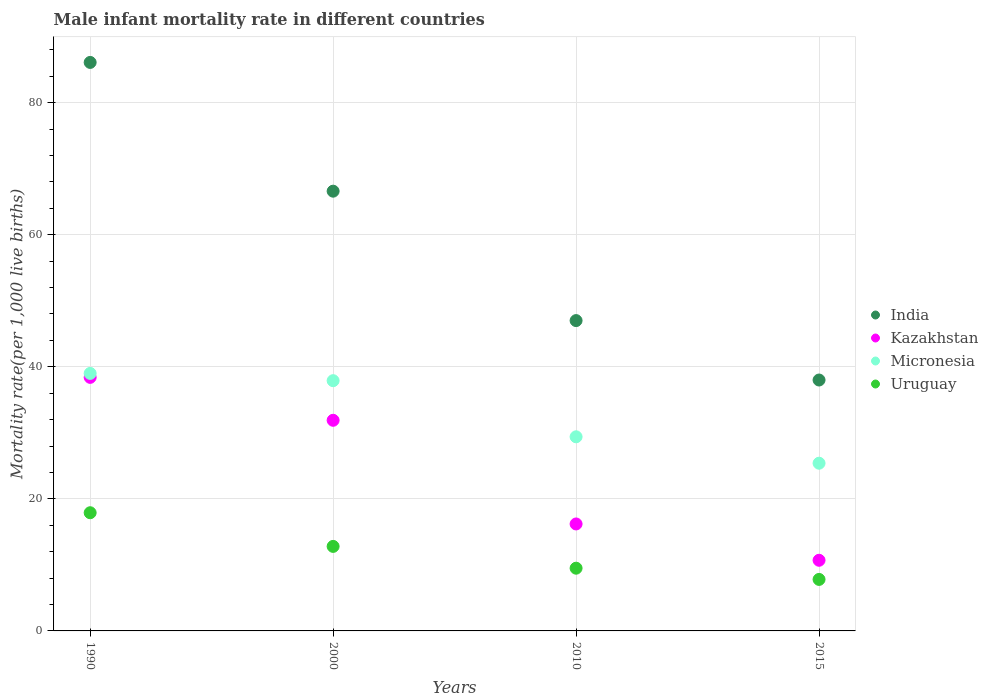Is the number of dotlines equal to the number of legend labels?
Your response must be concise. Yes. What is the male infant mortality rate in Micronesia in 2015?
Give a very brief answer. 25.4. Across all years, what is the maximum male infant mortality rate in Kazakhstan?
Give a very brief answer. 38.4. Across all years, what is the minimum male infant mortality rate in Kazakhstan?
Give a very brief answer. 10.7. In which year was the male infant mortality rate in Kazakhstan maximum?
Offer a very short reply. 1990. In which year was the male infant mortality rate in Micronesia minimum?
Provide a short and direct response. 2015. What is the total male infant mortality rate in Kazakhstan in the graph?
Ensure brevity in your answer.  97.2. What is the difference between the male infant mortality rate in Kazakhstan in 1990 and that in 2015?
Make the answer very short. 27.7. What is the difference between the male infant mortality rate in India in 2015 and the male infant mortality rate in Micronesia in 2000?
Make the answer very short. 0.1. What is the average male infant mortality rate in Kazakhstan per year?
Give a very brief answer. 24.3. In the year 2010, what is the difference between the male infant mortality rate in Micronesia and male infant mortality rate in India?
Give a very brief answer. -17.6. In how many years, is the male infant mortality rate in India greater than 72?
Offer a very short reply. 1. What is the ratio of the male infant mortality rate in India in 1990 to that in 2010?
Your answer should be compact. 1.83. Is the male infant mortality rate in Uruguay in 1990 less than that in 2015?
Your response must be concise. No. Is the difference between the male infant mortality rate in Micronesia in 2000 and 2010 greater than the difference between the male infant mortality rate in India in 2000 and 2010?
Give a very brief answer. No. What is the difference between the highest and the second highest male infant mortality rate in Uruguay?
Ensure brevity in your answer.  5.1. What is the difference between the highest and the lowest male infant mortality rate in India?
Offer a very short reply. 48.1. In how many years, is the male infant mortality rate in Kazakhstan greater than the average male infant mortality rate in Kazakhstan taken over all years?
Make the answer very short. 2. Does the male infant mortality rate in Uruguay monotonically increase over the years?
Provide a succinct answer. No. How many dotlines are there?
Your answer should be compact. 4. Does the graph contain grids?
Offer a terse response. Yes. Where does the legend appear in the graph?
Your answer should be very brief. Center right. What is the title of the graph?
Ensure brevity in your answer.  Male infant mortality rate in different countries. What is the label or title of the X-axis?
Your answer should be very brief. Years. What is the label or title of the Y-axis?
Give a very brief answer. Mortality rate(per 1,0 live births). What is the Mortality rate(per 1,000 live births) in India in 1990?
Give a very brief answer. 86.1. What is the Mortality rate(per 1,000 live births) in Kazakhstan in 1990?
Ensure brevity in your answer.  38.4. What is the Mortality rate(per 1,000 live births) in India in 2000?
Your response must be concise. 66.6. What is the Mortality rate(per 1,000 live births) of Kazakhstan in 2000?
Provide a succinct answer. 31.9. What is the Mortality rate(per 1,000 live births) in Micronesia in 2000?
Provide a succinct answer. 37.9. What is the Mortality rate(per 1,000 live births) of Kazakhstan in 2010?
Your response must be concise. 16.2. What is the Mortality rate(per 1,000 live births) in Micronesia in 2010?
Your response must be concise. 29.4. What is the Mortality rate(per 1,000 live births) of Kazakhstan in 2015?
Your answer should be very brief. 10.7. What is the Mortality rate(per 1,000 live births) of Micronesia in 2015?
Offer a terse response. 25.4. Across all years, what is the maximum Mortality rate(per 1,000 live births) of India?
Provide a succinct answer. 86.1. Across all years, what is the maximum Mortality rate(per 1,000 live births) in Kazakhstan?
Offer a terse response. 38.4. Across all years, what is the maximum Mortality rate(per 1,000 live births) in Micronesia?
Provide a succinct answer. 39. Across all years, what is the maximum Mortality rate(per 1,000 live births) of Uruguay?
Provide a succinct answer. 17.9. Across all years, what is the minimum Mortality rate(per 1,000 live births) of India?
Keep it short and to the point. 38. Across all years, what is the minimum Mortality rate(per 1,000 live births) in Micronesia?
Provide a succinct answer. 25.4. What is the total Mortality rate(per 1,000 live births) in India in the graph?
Keep it short and to the point. 237.7. What is the total Mortality rate(per 1,000 live births) of Kazakhstan in the graph?
Your answer should be compact. 97.2. What is the total Mortality rate(per 1,000 live births) of Micronesia in the graph?
Offer a very short reply. 131.7. What is the difference between the Mortality rate(per 1,000 live births) in India in 1990 and that in 2000?
Your answer should be very brief. 19.5. What is the difference between the Mortality rate(per 1,000 live births) of Kazakhstan in 1990 and that in 2000?
Keep it short and to the point. 6.5. What is the difference between the Mortality rate(per 1,000 live births) in Micronesia in 1990 and that in 2000?
Your answer should be very brief. 1.1. What is the difference between the Mortality rate(per 1,000 live births) of Uruguay in 1990 and that in 2000?
Your response must be concise. 5.1. What is the difference between the Mortality rate(per 1,000 live births) of India in 1990 and that in 2010?
Your answer should be compact. 39.1. What is the difference between the Mortality rate(per 1,000 live births) in Micronesia in 1990 and that in 2010?
Keep it short and to the point. 9.6. What is the difference between the Mortality rate(per 1,000 live births) in Uruguay in 1990 and that in 2010?
Provide a short and direct response. 8.4. What is the difference between the Mortality rate(per 1,000 live births) in India in 1990 and that in 2015?
Ensure brevity in your answer.  48.1. What is the difference between the Mortality rate(per 1,000 live births) of Kazakhstan in 1990 and that in 2015?
Your response must be concise. 27.7. What is the difference between the Mortality rate(per 1,000 live births) in Micronesia in 1990 and that in 2015?
Offer a very short reply. 13.6. What is the difference between the Mortality rate(per 1,000 live births) of India in 2000 and that in 2010?
Provide a short and direct response. 19.6. What is the difference between the Mortality rate(per 1,000 live births) of Micronesia in 2000 and that in 2010?
Ensure brevity in your answer.  8.5. What is the difference between the Mortality rate(per 1,000 live births) in Uruguay in 2000 and that in 2010?
Give a very brief answer. 3.3. What is the difference between the Mortality rate(per 1,000 live births) in India in 2000 and that in 2015?
Offer a terse response. 28.6. What is the difference between the Mortality rate(per 1,000 live births) in Kazakhstan in 2000 and that in 2015?
Offer a terse response. 21.2. What is the difference between the Mortality rate(per 1,000 live births) in India in 2010 and that in 2015?
Offer a terse response. 9. What is the difference between the Mortality rate(per 1,000 live births) of Kazakhstan in 2010 and that in 2015?
Keep it short and to the point. 5.5. What is the difference between the Mortality rate(per 1,000 live births) in Micronesia in 2010 and that in 2015?
Offer a very short reply. 4. What is the difference between the Mortality rate(per 1,000 live births) of India in 1990 and the Mortality rate(per 1,000 live births) of Kazakhstan in 2000?
Provide a succinct answer. 54.2. What is the difference between the Mortality rate(per 1,000 live births) of India in 1990 and the Mortality rate(per 1,000 live births) of Micronesia in 2000?
Provide a short and direct response. 48.2. What is the difference between the Mortality rate(per 1,000 live births) in India in 1990 and the Mortality rate(per 1,000 live births) in Uruguay in 2000?
Provide a short and direct response. 73.3. What is the difference between the Mortality rate(per 1,000 live births) of Kazakhstan in 1990 and the Mortality rate(per 1,000 live births) of Uruguay in 2000?
Ensure brevity in your answer.  25.6. What is the difference between the Mortality rate(per 1,000 live births) of Micronesia in 1990 and the Mortality rate(per 1,000 live births) of Uruguay in 2000?
Your answer should be compact. 26.2. What is the difference between the Mortality rate(per 1,000 live births) of India in 1990 and the Mortality rate(per 1,000 live births) of Kazakhstan in 2010?
Make the answer very short. 69.9. What is the difference between the Mortality rate(per 1,000 live births) in India in 1990 and the Mortality rate(per 1,000 live births) in Micronesia in 2010?
Provide a short and direct response. 56.7. What is the difference between the Mortality rate(per 1,000 live births) of India in 1990 and the Mortality rate(per 1,000 live births) of Uruguay in 2010?
Offer a very short reply. 76.6. What is the difference between the Mortality rate(per 1,000 live births) in Kazakhstan in 1990 and the Mortality rate(per 1,000 live births) in Uruguay in 2010?
Provide a short and direct response. 28.9. What is the difference between the Mortality rate(per 1,000 live births) of Micronesia in 1990 and the Mortality rate(per 1,000 live births) of Uruguay in 2010?
Ensure brevity in your answer.  29.5. What is the difference between the Mortality rate(per 1,000 live births) in India in 1990 and the Mortality rate(per 1,000 live births) in Kazakhstan in 2015?
Ensure brevity in your answer.  75.4. What is the difference between the Mortality rate(per 1,000 live births) in India in 1990 and the Mortality rate(per 1,000 live births) in Micronesia in 2015?
Your answer should be compact. 60.7. What is the difference between the Mortality rate(per 1,000 live births) in India in 1990 and the Mortality rate(per 1,000 live births) in Uruguay in 2015?
Offer a very short reply. 78.3. What is the difference between the Mortality rate(per 1,000 live births) in Kazakhstan in 1990 and the Mortality rate(per 1,000 live births) in Micronesia in 2015?
Provide a succinct answer. 13. What is the difference between the Mortality rate(per 1,000 live births) in Kazakhstan in 1990 and the Mortality rate(per 1,000 live births) in Uruguay in 2015?
Your response must be concise. 30.6. What is the difference between the Mortality rate(per 1,000 live births) in Micronesia in 1990 and the Mortality rate(per 1,000 live births) in Uruguay in 2015?
Ensure brevity in your answer.  31.2. What is the difference between the Mortality rate(per 1,000 live births) in India in 2000 and the Mortality rate(per 1,000 live births) in Kazakhstan in 2010?
Provide a short and direct response. 50.4. What is the difference between the Mortality rate(per 1,000 live births) of India in 2000 and the Mortality rate(per 1,000 live births) of Micronesia in 2010?
Your answer should be compact. 37.2. What is the difference between the Mortality rate(per 1,000 live births) in India in 2000 and the Mortality rate(per 1,000 live births) in Uruguay in 2010?
Your answer should be compact. 57.1. What is the difference between the Mortality rate(per 1,000 live births) in Kazakhstan in 2000 and the Mortality rate(per 1,000 live births) in Uruguay in 2010?
Offer a terse response. 22.4. What is the difference between the Mortality rate(per 1,000 live births) of Micronesia in 2000 and the Mortality rate(per 1,000 live births) of Uruguay in 2010?
Ensure brevity in your answer.  28.4. What is the difference between the Mortality rate(per 1,000 live births) in India in 2000 and the Mortality rate(per 1,000 live births) in Kazakhstan in 2015?
Make the answer very short. 55.9. What is the difference between the Mortality rate(per 1,000 live births) in India in 2000 and the Mortality rate(per 1,000 live births) in Micronesia in 2015?
Your answer should be very brief. 41.2. What is the difference between the Mortality rate(per 1,000 live births) of India in 2000 and the Mortality rate(per 1,000 live births) of Uruguay in 2015?
Your answer should be compact. 58.8. What is the difference between the Mortality rate(per 1,000 live births) in Kazakhstan in 2000 and the Mortality rate(per 1,000 live births) in Uruguay in 2015?
Your response must be concise. 24.1. What is the difference between the Mortality rate(per 1,000 live births) of Micronesia in 2000 and the Mortality rate(per 1,000 live births) of Uruguay in 2015?
Offer a very short reply. 30.1. What is the difference between the Mortality rate(per 1,000 live births) in India in 2010 and the Mortality rate(per 1,000 live births) in Kazakhstan in 2015?
Provide a succinct answer. 36.3. What is the difference between the Mortality rate(per 1,000 live births) in India in 2010 and the Mortality rate(per 1,000 live births) in Micronesia in 2015?
Provide a succinct answer. 21.6. What is the difference between the Mortality rate(per 1,000 live births) of India in 2010 and the Mortality rate(per 1,000 live births) of Uruguay in 2015?
Make the answer very short. 39.2. What is the difference between the Mortality rate(per 1,000 live births) of Kazakhstan in 2010 and the Mortality rate(per 1,000 live births) of Micronesia in 2015?
Your answer should be very brief. -9.2. What is the difference between the Mortality rate(per 1,000 live births) in Kazakhstan in 2010 and the Mortality rate(per 1,000 live births) in Uruguay in 2015?
Provide a short and direct response. 8.4. What is the difference between the Mortality rate(per 1,000 live births) in Micronesia in 2010 and the Mortality rate(per 1,000 live births) in Uruguay in 2015?
Your answer should be very brief. 21.6. What is the average Mortality rate(per 1,000 live births) in India per year?
Your answer should be very brief. 59.42. What is the average Mortality rate(per 1,000 live births) in Kazakhstan per year?
Offer a very short reply. 24.3. What is the average Mortality rate(per 1,000 live births) of Micronesia per year?
Your answer should be very brief. 32.92. In the year 1990, what is the difference between the Mortality rate(per 1,000 live births) in India and Mortality rate(per 1,000 live births) in Kazakhstan?
Provide a succinct answer. 47.7. In the year 1990, what is the difference between the Mortality rate(per 1,000 live births) of India and Mortality rate(per 1,000 live births) of Micronesia?
Make the answer very short. 47.1. In the year 1990, what is the difference between the Mortality rate(per 1,000 live births) in India and Mortality rate(per 1,000 live births) in Uruguay?
Your answer should be very brief. 68.2. In the year 1990, what is the difference between the Mortality rate(per 1,000 live births) of Kazakhstan and Mortality rate(per 1,000 live births) of Micronesia?
Your answer should be compact. -0.6. In the year 1990, what is the difference between the Mortality rate(per 1,000 live births) of Kazakhstan and Mortality rate(per 1,000 live births) of Uruguay?
Make the answer very short. 20.5. In the year 1990, what is the difference between the Mortality rate(per 1,000 live births) in Micronesia and Mortality rate(per 1,000 live births) in Uruguay?
Your answer should be compact. 21.1. In the year 2000, what is the difference between the Mortality rate(per 1,000 live births) of India and Mortality rate(per 1,000 live births) of Kazakhstan?
Offer a very short reply. 34.7. In the year 2000, what is the difference between the Mortality rate(per 1,000 live births) in India and Mortality rate(per 1,000 live births) in Micronesia?
Your answer should be very brief. 28.7. In the year 2000, what is the difference between the Mortality rate(per 1,000 live births) in India and Mortality rate(per 1,000 live births) in Uruguay?
Offer a very short reply. 53.8. In the year 2000, what is the difference between the Mortality rate(per 1,000 live births) of Kazakhstan and Mortality rate(per 1,000 live births) of Micronesia?
Your answer should be very brief. -6. In the year 2000, what is the difference between the Mortality rate(per 1,000 live births) of Kazakhstan and Mortality rate(per 1,000 live births) of Uruguay?
Your response must be concise. 19.1. In the year 2000, what is the difference between the Mortality rate(per 1,000 live births) in Micronesia and Mortality rate(per 1,000 live births) in Uruguay?
Offer a terse response. 25.1. In the year 2010, what is the difference between the Mortality rate(per 1,000 live births) of India and Mortality rate(per 1,000 live births) of Kazakhstan?
Give a very brief answer. 30.8. In the year 2010, what is the difference between the Mortality rate(per 1,000 live births) in India and Mortality rate(per 1,000 live births) in Micronesia?
Your response must be concise. 17.6. In the year 2010, what is the difference between the Mortality rate(per 1,000 live births) of India and Mortality rate(per 1,000 live births) of Uruguay?
Make the answer very short. 37.5. In the year 2010, what is the difference between the Mortality rate(per 1,000 live births) of Kazakhstan and Mortality rate(per 1,000 live births) of Micronesia?
Ensure brevity in your answer.  -13.2. In the year 2015, what is the difference between the Mortality rate(per 1,000 live births) in India and Mortality rate(per 1,000 live births) in Kazakhstan?
Your response must be concise. 27.3. In the year 2015, what is the difference between the Mortality rate(per 1,000 live births) of India and Mortality rate(per 1,000 live births) of Uruguay?
Provide a succinct answer. 30.2. In the year 2015, what is the difference between the Mortality rate(per 1,000 live births) in Kazakhstan and Mortality rate(per 1,000 live births) in Micronesia?
Make the answer very short. -14.7. In the year 2015, what is the difference between the Mortality rate(per 1,000 live births) of Kazakhstan and Mortality rate(per 1,000 live births) of Uruguay?
Give a very brief answer. 2.9. In the year 2015, what is the difference between the Mortality rate(per 1,000 live births) of Micronesia and Mortality rate(per 1,000 live births) of Uruguay?
Offer a terse response. 17.6. What is the ratio of the Mortality rate(per 1,000 live births) of India in 1990 to that in 2000?
Provide a succinct answer. 1.29. What is the ratio of the Mortality rate(per 1,000 live births) in Kazakhstan in 1990 to that in 2000?
Your response must be concise. 1.2. What is the ratio of the Mortality rate(per 1,000 live births) of Micronesia in 1990 to that in 2000?
Give a very brief answer. 1.03. What is the ratio of the Mortality rate(per 1,000 live births) in Uruguay in 1990 to that in 2000?
Give a very brief answer. 1.4. What is the ratio of the Mortality rate(per 1,000 live births) of India in 1990 to that in 2010?
Offer a very short reply. 1.83. What is the ratio of the Mortality rate(per 1,000 live births) in Kazakhstan in 1990 to that in 2010?
Offer a very short reply. 2.37. What is the ratio of the Mortality rate(per 1,000 live births) of Micronesia in 1990 to that in 2010?
Keep it short and to the point. 1.33. What is the ratio of the Mortality rate(per 1,000 live births) of Uruguay in 1990 to that in 2010?
Offer a terse response. 1.88. What is the ratio of the Mortality rate(per 1,000 live births) in India in 1990 to that in 2015?
Make the answer very short. 2.27. What is the ratio of the Mortality rate(per 1,000 live births) in Kazakhstan in 1990 to that in 2015?
Ensure brevity in your answer.  3.59. What is the ratio of the Mortality rate(per 1,000 live births) in Micronesia in 1990 to that in 2015?
Your answer should be very brief. 1.54. What is the ratio of the Mortality rate(per 1,000 live births) of Uruguay in 1990 to that in 2015?
Make the answer very short. 2.29. What is the ratio of the Mortality rate(per 1,000 live births) in India in 2000 to that in 2010?
Make the answer very short. 1.42. What is the ratio of the Mortality rate(per 1,000 live births) in Kazakhstan in 2000 to that in 2010?
Make the answer very short. 1.97. What is the ratio of the Mortality rate(per 1,000 live births) in Micronesia in 2000 to that in 2010?
Your response must be concise. 1.29. What is the ratio of the Mortality rate(per 1,000 live births) of Uruguay in 2000 to that in 2010?
Provide a short and direct response. 1.35. What is the ratio of the Mortality rate(per 1,000 live births) in India in 2000 to that in 2015?
Ensure brevity in your answer.  1.75. What is the ratio of the Mortality rate(per 1,000 live births) of Kazakhstan in 2000 to that in 2015?
Give a very brief answer. 2.98. What is the ratio of the Mortality rate(per 1,000 live births) in Micronesia in 2000 to that in 2015?
Your answer should be very brief. 1.49. What is the ratio of the Mortality rate(per 1,000 live births) in Uruguay in 2000 to that in 2015?
Give a very brief answer. 1.64. What is the ratio of the Mortality rate(per 1,000 live births) of India in 2010 to that in 2015?
Keep it short and to the point. 1.24. What is the ratio of the Mortality rate(per 1,000 live births) of Kazakhstan in 2010 to that in 2015?
Your answer should be very brief. 1.51. What is the ratio of the Mortality rate(per 1,000 live births) in Micronesia in 2010 to that in 2015?
Make the answer very short. 1.16. What is the ratio of the Mortality rate(per 1,000 live births) in Uruguay in 2010 to that in 2015?
Offer a very short reply. 1.22. What is the difference between the highest and the second highest Mortality rate(per 1,000 live births) of India?
Give a very brief answer. 19.5. What is the difference between the highest and the second highest Mortality rate(per 1,000 live births) of Kazakhstan?
Make the answer very short. 6.5. What is the difference between the highest and the second highest Mortality rate(per 1,000 live births) in Uruguay?
Provide a short and direct response. 5.1. What is the difference between the highest and the lowest Mortality rate(per 1,000 live births) of India?
Your response must be concise. 48.1. What is the difference between the highest and the lowest Mortality rate(per 1,000 live births) of Kazakhstan?
Offer a terse response. 27.7. What is the difference between the highest and the lowest Mortality rate(per 1,000 live births) in Micronesia?
Offer a terse response. 13.6. 